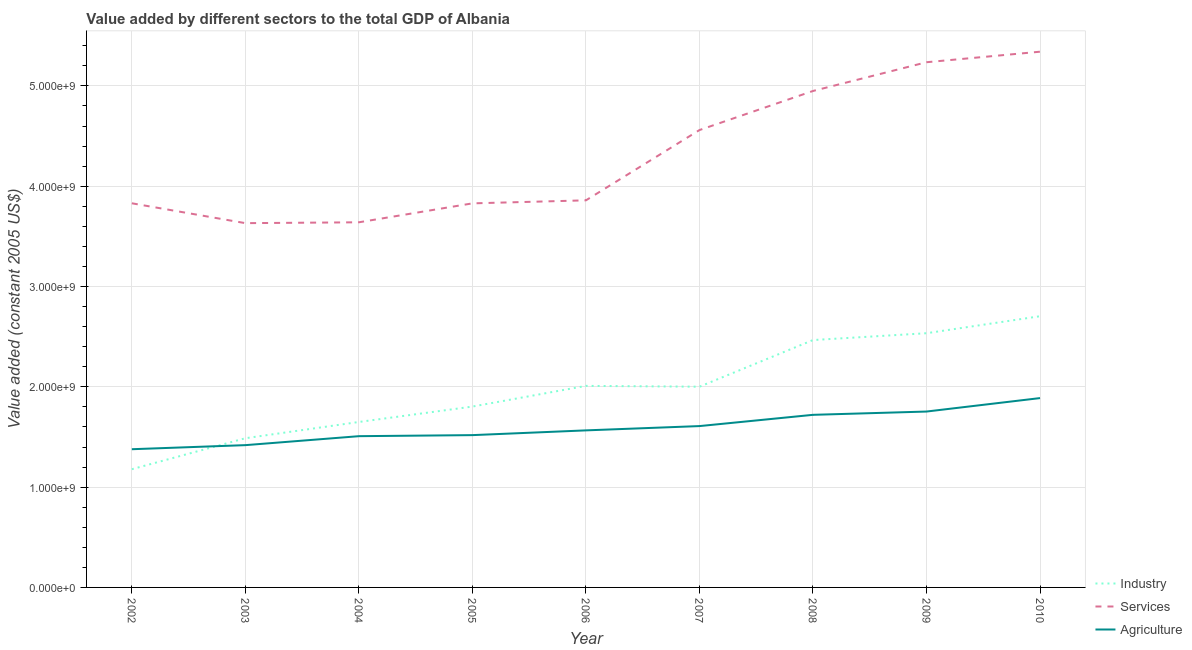Does the line corresponding to value added by services intersect with the line corresponding to value added by agricultural sector?
Your answer should be very brief. No. Is the number of lines equal to the number of legend labels?
Make the answer very short. Yes. What is the value added by industrial sector in 2009?
Provide a succinct answer. 2.53e+09. Across all years, what is the maximum value added by industrial sector?
Provide a short and direct response. 2.70e+09. Across all years, what is the minimum value added by industrial sector?
Offer a terse response. 1.18e+09. In which year was the value added by agricultural sector maximum?
Offer a terse response. 2010. What is the total value added by services in the graph?
Provide a short and direct response. 3.89e+1. What is the difference between the value added by industrial sector in 2008 and that in 2009?
Your answer should be very brief. -6.81e+07. What is the difference between the value added by industrial sector in 2008 and the value added by agricultural sector in 2005?
Your answer should be very brief. 9.48e+08. What is the average value added by agricultural sector per year?
Offer a terse response. 1.60e+09. In the year 2002, what is the difference between the value added by industrial sector and value added by services?
Give a very brief answer. -2.65e+09. What is the ratio of the value added by industrial sector in 2007 to that in 2010?
Ensure brevity in your answer.  0.74. What is the difference between the highest and the second highest value added by services?
Provide a succinct answer. 1.05e+08. What is the difference between the highest and the lowest value added by industrial sector?
Give a very brief answer. 1.53e+09. Is it the case that in every year, the sum of the value added by industrial sector and value added by services is greater than the value added by agricultural sector?
Your answer should be compact. Yes. Is the value added by services strictly greater than the value added by industrial sector over the years?
Your response must be concise. Yes. Is the value added by services strictly less than the value added by industrial sector over the years?
Keep it short and to the point. No. How many lines are there?
Your response must be concise. 3. What is the difference between two consecutive major ticks on the Y-axis?
Give a very brief answer. 1.00e+09. Are the values on the major ticks of Y-axis written in scientific E-notation?
Ensure brevity in your answer.  Yes. Does the graph contain grids?
Offer a very short reply. Yes. How are the legend labels stacked?
Offer a terse response. Vertical. What is the title of the graph?
Provide a short and direct response. Value added by different sectors to the total GDP of Albania. Does "Tertiary education" appear as one of the legend labels in the graph?
Provide a short and direct response. No. What is the label or title of the Y-axis?
Give a very brief answer. Value added (constant 2005 US$). What is the Value added (constant 2005 US$) in Industry in 2002?
Give a very brief answer. 1.18e+09. What is the Value added (constant 2005 US$) of Services in 2002?
Your answer should be very brief. 3.83e+09. What is the Value added (constant 2005 US$) in Agriculture in 2002?
Offer a very short reply. 1.38e+09. What is the Value added (constant 2005 US$) in Industry in 2003?
Your answer should be compact. 1.49e+09. What is the Value added (constant 2005 US$) of Services in 2003?
Your answer should be very brief. 3.63e+09. What is the Value added (constant 2005 US$) of Agriculture in 2003?
Ensure brevity in your answer.  1.42e+09. What is the Value added (constant 2005 US$) in Industry in 2004?
Offer a terse response. 1.65e+09. What is the Value added (constant 2005 US$) in Services in 2004?
Offer a terse response. 3.64e+09. What is the Value added (constant 2005 US$) in Agriculture in 2004?
Provide a succinct answer. 1.51e+09. What is the Value added (constant 2005 US$) in Industry in 2005?
Your answer should be very brief. 1.80e+09. What is the Value added (constant 2005 US$) of Services in 2005?
Make the answer very short. 3.83e+09. What is the Value added (constant 2005 US$) in Agriculture in 2005?
Your answer should be compact. 1.52e+09. What is the Value added (constant 2005 US$) of Industry in 2006?
Offer a terse response. 2.01e+09. What is the Value added (constant 2005 US$) in Services in 2006?
Keep it short and to the point. 3.86e+09. What is the Value added (constant 2005 US$) of Agriculture in 2006?
Provide a succinct answer. 1.57e+09. What is the Value added (constant 2005 US$) in Industry in 2007?
Give a very brief answer. 2.00e+09. What is the Value added (constant 2005 US$) in Services in 2007?
Provide a short and direct response. 4.56e+09. What is the Value added (constant 2005 US$) in Agriculture in 2007?
Your answer should be very brief. 1.61e+09. What is the Value added (constant 2005 US$) in Industry in 2008?
Give a very brief answer. 2.47e+09. What is the Value added (constant 2005 US$) of Services in 2008?
Your response must be concise. 4.95e+09. What is the Value added (constant 2005 US$) in Agriculture in 2008?
Offer a very short reply. 1.72e+09. What is the Value added (constant 2005 US$) of Industry in 2009?
Keep it short and to the point. 2.53e+09. What is the Value added (constant 2005 US$) of Services in 2009?
Your answer should be very brief. 5.24e+09. What is the Value added (constant 2005 US$) of Agriculture in 2009?
Your answer should be compact. 1.75e+09. What is the Value added (constant 2005 US$) of Industry in 2010?
Keep it short and to the point. 2.70e+09. What is the Value added (constant 2005 US$) of Services in 2010?
Provide a short and direct response. 5.34e+09. What is the Value added (constant 2005 US$) in Agriculture in 2010?
Your answer should be compact. 1.89e+09. Across all years, what is the maximum Value added (constant 2005 US$) in Industry?
Your answer should be very brief. 2.70e+09. Across all years, what is the maximum Value added (constant 2005 US$) in Services?
Make the answer very short. 5.34e+09. Across all years, what is the maximum Value added (constant 2005 US$) in Agriculture?
Offer a terse response. 1.89e+09. Across all years, what is the minimum Value added (constant 2005 US$) in Industry?
Ensure brevity in your answer.  1.18e+09. Across all years, what is the minimum Value added (constant 2005 US$) of Services?
Offer a very short reply. 3.63e+09. Across all years, what is the minimum Value added (constant 2005 US$) of Agriculture?
Keep it short and to the point. 1.38e+09. What is the total Value added (constant 2005 US$) in Industry in the graph?
Keep it short and to the point. 1.78e+1. What is the total Value added (constant 2005 US$) in Services in the graph?
Your answer should be very brief. 3.89e+1. What is the total Value added (constant 2005 US$) in Agriculture in the graph?
Your answer should be very brief. 1.44e+1. What is the difference between the Value added (constant 2005 US$) in Industry in 2002 and that in 2003?
Provide a short and direct response. -3.09e+08. What is the difference between the Value added (constant 2005 US$) in Services in 2002 and that in 2003?
Offer a terse response. 1.98e+08. What is the difference between the Value added (constant 2005 US$) of Agriculture in 2002 and that in 2003?
Your answer should be compact. -4.06e+07. What is the difference between the Value added (constant 2005 US$) in Industry in 2002 and that in 2004?
Ensure brevity in your answer.  -4.71e+08. What is the difference between the Value added (constant 2005 US$) of Services in 2002 and that in 2004?
Ensure brevity in your answer.  1.90e+08. What is the difference between the Value added (constant 2005 US$) in Agriculture in 2002 and that in 2004?
Your response must be concise. -1.30e+08. What is the difference between the Value added (constant 2005 US$) of Industry in 2002 and that in 2005?
Make the answer very short. -6.24e+08. What is the difference between the Value added (constant 2005 US$) of Services in 2002 and that in 2005?
Make the answer very short. 7.24e+05. What is the difference between the Value added (constant 2005 US$) of Agriculture in 2002 and that in 2005?
Your response must be concise. -1.40e+08. What is the difference between the Value added (constant 2005 US$) in Industry in 2002 and that in 2006?
Your answer should be compact. -8.31e+08. What is the difference between the Value added (constant 2005 US$) of Services in 2002 and that in 2006?
Ensure brevity in your answer.  -2.94e+07. What is the difference between the Value added (constant 2005 US$) in Agriculture in 2002 and that in 2006?
Provide a succinct answer. -1.88e+08. What is the difference between the Value added (constant 2005 US$) in Industry in 2002 and that in 2007?
Give a very brief answer. -8.23e+08. What is the difference between the Value added (constant 2005 US$) of Services in 2002 and that in 2007?
Your response must be concise. -7.30e+08. What is the difference between the Value added (constant 2005 US$) in Agriculture in 2002 and that in 2007?
Give a very brief answer. -2.31e+08. What is the difference between the Value added (constant 2005 US$) in Industry in 2002 and that in 2008?
Ensure brevity in your answer.  -1.29e+09. What is the difference between the Value added (constant 2005 US$) of Services in 2002 and that in 2008?
Provide a succinct answer. -1.12e+09. What is the difference between the Value added (constant 2005 US$) in Agriculture in 2002 and that in 2008?
Your answer should be compact. -3.43e+08. What is the difference between the Value added (constant 2005 US$) of Industry in 2002 and that in 2009?
Ensure brevity in your answer.  -1.36e+09. What is the difference between the Value added (constant 2005 US$) of Services in 2002 and that in 2009?
Your response must be concise. -1.41e+09. What is the difference between the Value added (constant 2005 US$) in Agriculture in 2002 and that in 2009?
Give a very brief answer. -3.76e+08. What is the difference between the Value added (constant 2005 US$) in Industry in 2002 and that in 2010?
Provide a succinct answer. -1.53e+09. What is the difference between the Value added (constant 2005 US$) in Services in 2002 and that in 2010?
Provide a succinct answer. -1.51e+09. What is the difference between the Value added (constant 2005 US$) in Agriculture in 2002 and that in 2010?
Offer a terse response. -5.10e+08. What is the difference between the Value added (constant 2005 US$) in Industry in 2003 and that in 2004?
Ensure brevity in your answer.  -1.62e+08. What is the difference between the Value added (constant 2005 US$) of Services in 2003 and that in 2004?
Give a very brief answer. -8.49e+06. What is the difference between the Value added (constant 2005 US$) in Agriculture in 2003 and that in 2004?
Ensure brevity in your answer.  -8.94e+07. What is the difference between the Value added (constant 2005 US$) of Industry in 2003 and that in 2005?
Provide a succinct answer. -3.16e+08. What is the difference between the Value added (constant 2005 US$) in Services in 2003 and that in 2005?
Make the answer very short. -1.97e+08. What is the difference between the Value added (constant 2005 US$) in Agriculture in 2003 and that in 2005?
Provide a succinct answer. -9.99e+07. What is the difference between the Value added (constant 2005 US$) in Industry in 2003 and that in 2006?
Keep it short and to the point. -5.22e+08. What is the difference between the Value added (constant 2005 US$) in Services in 2003 and that in 2006?
Your response must be concise. -2.27e+08. What is the difference between the Value added (constant 2005 US$) of Agriculture in 2003 and that in 2006?
Provide a short and direct response. -1.47e+08. What is the difference between the Value added (constant 2005 US$) in Industry in 2003 and that in 2007?
Offer a very short reply. -5.14e+08. What is the difference between the Value added (constant 2005 US$) in Services in 2003 and that in 2007?
Offer a very short reply. -9.28e+08. What is the difference between the Value added (constant 2005 US$) of Agriculture in 2003 and that in 2007?
Your answer should be compact. -1.90e+08. What is the difference between the Value added (constant 2005 US$) of Industry in 2003 and that in 2008?
Your answer should be compact. -9.79e+08. What is the difference between the Value added (constant 2005 US$) of Services in 2003 and that in 2008?
Your response must be concise. -1.32e+09. What is the difference between the Value added (constant 2005 US$) of Agriculture in 2003 and that in 2008?
Make the answer very short. -3.02e+08. What is the difference between the Value added (constant 2005 US$) in Industry in 2003 and that in 2009?
Keep it short and to the point. -1.05e+09. What is the difference between the Value added (constant 2005 US$) in Services in 2003 and that in 2009?
Keep it short and to the point. -1.60e+09. What is the difference between the Value added (constant 2005 US$) in Agriculture in 2003 and that in 2009?
Your response must be concise. -3.35e+08. What is the difference between the Value added (constant 2005 US$) in Industry in 2003 and that in 2010?
Offer a terse response. -1.22e+09. What is the difference between the Value added (constant 2005 US$) of Services in 2003 and that in 2010?
Ensure brevity in your answer.  -1.71e+09. What is the difference between the Value added (constant 2005 US$) of Agriculture in 2003 and that in 2010?
Make the answer very short. -4.69e+08. What is the difference between the Value added (constant 2005 US$) of Industry in 2004 and that in 2005?
Make the answer very short. -1.54e+08. What is the difference between the Value added (constant 2005 US$) of Services in 2004 and that in 2005?
Make the answer very short. -1.89e+08. What is the difference between the Value added (constant 2005 US$) in Agriculture in 2004 and that in 2005?
Provide a succinct answer. -1.05e+07. What is the difference between the Value added (constant 2005 US$) in Industry in 2004 and that in 2006?
Your answer should be very brief. -3.60e+08. What is the difference between the Value added (constant 2005 US$) in Services in 2004 and that in 2006?
Your answer should be compact. -2.19e+08. What is the difference between the Value added (constant 2005 US$) of Agriculture in 2004 and that in 2006?
Offer a terse response. -5.79e+07. What is the difference between the Value added (constant 2005 US$) of Industry in 2004 and that in 2007?
Provide a succinct answer. -3.52e+08. What is the difference between the Value added (constant 2005 US$) in Services in 2004 and that in 2007?
Give a very brief answer. -9.20e+08. What is the difference between the Value added (constant 2005 US$) of Agriculture in 2004 and that in 2007?
Make the answer very short. -1.01e+08. What is the difference between the Value added (constant 2005 US$) in Industry in 2004 and that in 2008?
Your response must be concise. -8.17e+08. What is the difference between the Value added (constant 2005 US$) of Services in 2004 and that in 2008?
Your response must be concise. -1.31e+09. What is the difference between the Value added (constant 2005 US$) of Agriculture in 2004 and that in 2008?
Provide a succinct answer. -2.13e+08. What is the difference between the Value added (constant 2005 US$) in Industry in 2004 and that in 2009?
Provide a short and direct response. -8.85e+08. What is the difference between the Value added (constant 2005 US$) in Services in 2004 and that in 2009?
Offer a terse response. -1.60e+09. What is the difference between the Value added (constant 2005 US$) in Agriculture in 2004 and that in 2009?
Give a very brief answer. -2.46e+08. What is the difference between the Value added (constant 2005 US$) of Industry in 2004 and that in 2010?
Provide a short and direct response. -1.05e+09. What is the difference between the Value added (constant 2005 US$) of Services in 2004 and that in 2010?
Ensure brevity in your answer.  -1.70e+09. What is the difference between the Value added (constant 2005 US$) of Agriculture in 2004 and that in 2010?
Give a very brief answer. -3.80e+08. What is the difference between the Value added (constant 2005 US$) of Industry in 2005 and that in 2006?
Provide a succinct answer. -2.06e+08. What is the difference between the Value added (constant 2005 US$) of Services in 2005 and that in 2006?
Offer a terse response. -3.01e+07. What is the difference between the Value added (constant 2005 US$) in Agriculture in 2005 and that in 2006?
Provide a short and direct response. -4.75e+07. What is the difference between the Value added (constant 2005 US$) in Industry in 2005 and that in 2007?
Ensure brevity in your answer.  -1.98e+08. What is the difference between the Value added (constant 2005 US$) of Services in 2005 and that in 2007?
Offer a terse response. -7.31e+08. What is the difference between the Value added (constant 2005 US$) of Agriculture in 2005 and that in 2007?
Provide a succinct answer. -9.02e+07. What is the difference between the Value added (constant 2005 US$) of Industry in 2005 and that in 2008?
Provide a succinct answer. -6.63e+08. What is the difference between the Value added (constant 2005 US$) in Services in 2005 and that in 2008?
Your answer should be very brief. -1.12e+09. What is the difference between the Value added (constant 2005 US$) of Agriculture in 2005 and that in 2008?
Offer a terse response. -2.02e+08. What is the difference between the Value added (constant 2005 US$) in Industry in 2005 and that in 2009?
Your response must be concise. -7.31e+08. What is the difference between the Value added (constant 2005 US$) in Services in 2005 and that in 2009?
Make the answer very short. -1.41e+09. What is the difference between the Value added (constant 2005 US$) in Agriculture in 2005 and that in 2009?
Offer a very short reply. -2.35e+08. What is the difference between the Value added (constant 2005 US$) in Industry in 2005 and that in 2010?
Provide a succinct answer. -9.01e+08. What is the difference between the Value added (constant 2005 US$) of Services in 2005 and that in 2010?
Provide a succinct answer. -1.51e+09. What is the difference between the Value added (constant 2005 US$) of Agriculture in 2005 and that in 2010?
Give a very brief answer. -3.69e+08. What is the difference between the Value added (constant 2005 US$) of Industry in 2006 and that in 2007?
Give a very brief answer. 8.20e+06. What is the difference between the Value added (constant 2005 US$) in Services in 2006 and that in 2007?
Keep it short and to the point. -7.01e+08. What is the difference between the Value added (constant 2005 US$) in Agriculture in 2006 and that in 2007?
Your response must be concise. -4.27e+07. What is the difference between the Value added (constant 2005 US$) in Industry in 2006 and that in 2008?
Your answer should be very brief. -4.57e+08. What is the difference between the Value added (constant 2005 US$) in Services in 2006 and that in 2008?
Provide a short and direct response. -1.09e+09. What is the difference between the Value added (constant 2005 US$) in Agriculture in 2006 and that in 2008?
Your answer should be very brief. -1.55e+08. What is the difference between the Value added (constant 2005 US$) in Industry in 2006 and that in 2009?
Provide a succinct answer. -5.25e+08. What is the difference between the Value added (constant 2005 US$) of Services in 2006 and that in 2009?
Keep it short and to the point. -1.38e+09. What is the difference between the Value added (constant 2005 US$) in Agriculture in 2006 and that in 2009?
Give a very brief answer. -1.88e+08. What is the difference between the Value added (constant 2005 US$) in Industry in 2006 and that in 2010?
Make the answer very short. -6.94e+08. What is the difference between the Value added (constant 2005 US$) in Services in 2006 and that in 2010?
Your answer should be very brief. -1.48e+09. What is the difference between the Value added (constant 2005 US$) of Agriculture in 2006 and that in 2010?
Your answer should be compact. -3.22e+08. What is the difference between the Value added (constant 2005 US$) of Industry in 2007 and that in 2008?
Offer a very short reply. -4.65e+08. What is the difference between the Value added (constant 2005 US$) in Services in 2007 and that in 2008?
Offer a very short reply. -3.90e+08. What is the difference between the Value added (constant 2005 US$) of Agriculture in 2007 and that in 2008?
Offer a very short reply. -1.12e+08. What is the difference between the Value added (constant 2005 US$) of Industry in 2007 and that in 2009?
Make the answer very short. -5.33e+08. What is the difference between the Value added (constant 2005 US$) in Services in 2007 and that in 2009?
Provide a succinct answer. -6.76e+08. What is the difference between the Value added (constant 2005 US$) in Agriculture in 2007 and that in 2009?
Make the answer very short. -1.45e+08. What is the difference between the Value added (constant 2005 US$) of Industry in 2007 and that in 2010?
Provide a short and direct response. -7.03e+08. What is the difference between the Value added (constant 2005 US$) in Services in 2007 and that in 2010?
Your answer should be very brief. -7.81e+08. What is the difference between the Value added (constant 2005 US$) in Agriculture in 2007 and that in 2010?
Provide a short and direct response. -2.79e+08. What is the difference between the Value added (constant 2005 US$) in Industry in 2008 and that in 2009?
Offer a terse response. -6.81e+07. What is the difference between the Value added (constant 2005 US$) in Services in 2008 and that in 2009?
Ensure brevity in your answer.  -2.87e+08. What is the difference between the Value added (constant 2005 US$) of Agriculture in 2008 and that in 2009?
Keep it short and to the point. -3.28e+07. What is the difference between the Value added (constant 2005 US$) of Industry in 2008 and that in 2010?
Give a very brief answer. -2.38e+08. What is the difference between the Value added (constant 2005 US$) in Services in 2008 and that in 2010?
Your answer should be compact. -3.92e+08. What is the difference between the Value added (constant 2005 US$) of Agriculture in 2008 and that in 2010?
Give a very brief answer. -1.67e+08. What is the difference between the Value added (constant 2005 US$) of Industry in 2009 and that in 2010?
Your response must be concise. -1.69e+08. What is the difference between the Value added (constant 2005 US$) of Services in 2009 and that in 2010?
Your answer should be compact. -1.05e+08. What is the difference between the Value added (constant 2005 US$) in Agriculture in 2009 and that in 2010?
Provide a short and direct response. -1.34e+08. What is the difference between the Value added (constant 2005 US$) in Industry in 2002 and the Value added (constant 2005 US$) in Services in 2003?
Provide a short and direct response. -2.45e+09. What is the difference between the Value added (constant 2005 US$) in Industry in 2002 and the Value added (constant 2005 US$) in Agriculture in 2003?
Make the answer very short. -2.40e+08. What is the difference between the Value added (constant 2005 US$) of Services in 2002 and the Value added (constant 2005 US$) of Agriculture in 2003?
Give a very brief answer. 2.41e+09. What is the difference between the Value added (constant 2005 US$) of Industry in 2002 and the Value added (constant 2005 US$) of Services in 2004?
Your response must be concise. -2.46e+09. What is the difference between the Value added (constant 2005 US$) of Industry in 2002 and the Value added (constant 2005 US$) of Agriculture in 2004?
Your answer should be compact. -3.29e+08. What is the difference between the Value added (constant 2005 US$) in Services in 2002 and the Value added (constant 2005 US$) in Agriculture in 2004?
Give a very brief answer. 2.32e+09. What is the difference between the Value added (constant 2005 US$) in Industry in 2002 and the Value added (constant 2005 US$) in Services in 2005?
Your response must be concise. -2.65e+09. What is the difference between the Value added (constant 2005 US$) in Industry in 2002 and the Value added (constant 2005 US$) in Agriculture in 2005?
Make the answer very short. -3.40e+08. What is the difference between the Value added (constant 2005 US$) in Services in 2002 and the Value added (constant 2005 US$) in Agriculture in 2005?
Ensure brevity in your answer.  2.31e+09. What is the difference between the Value added (constant 2005 US$) of Industry in 2002 and the Value added (constant 2005 US$) of Services in 2006?
Offer a terse response. -2.68e+09. What is the difference between the Value added (constant 2005 US$) of Industry in 2002 and the Value added (constant 2005 US$) of Agriculture in 2006?
Your response must be concise. -3.87e+08. What is the difference between the Value added (constant 2005 US$) of Services in 2002 and the Value added (constant 2005 US$) of Agriculture in 2006?
Provide a short and direct response. 2.26e+09. What is the difference between the Value added (constant 2005 US$) of Industry in 2002 and the Value added (constant 2005 US$) of Services in 2007?
Your response must be concise. -3.38e+09. What is the difference between the Value added (constant 2005 US$) in Industry in 2002 and the Value added (constant 2005 US$) in Agriculture in 2007?
Your answer should be very brief. -4.30e+08. What is the difference between the Value added (constant 2005 US$) of Services in 2002 and the Value added (constant 2005 US$) of Agriculture in 2007?
Make the answer very short. 2.22e+09. What is the difference between the Value added (constant 2005 US$) in Industry in 2002 and the Value added (constant 2005 US$) in Services in 2008?
Offer a terse response. -3.77e+09. What is the difference between the Value added (constant 2005 US$) in Industry in 2002 and the Value added (constant 2005 US$) in Agriculture in 2008?
Make the answer very short. -5.42e+08. What is the difference between the Value added (constant 2005 US$) of Services in 2002 and the Value added (constant 2005 US$) of Agriculture in 2008?
Make the answer very short. 2.11e+09. What is the difference between the Value added (constant 2005 US$) of Industry in 2002 and the Value added (constant 2005 US$) of Services in 2009?
Provide a short and direct response. -4.06e+09. What is the difference between the Value added (constant 2005 US$) in Industry in 2002 and the Value added (constant 2005 US$) in Agriculture in 2009?
Give a very brief answer. -5.75e+08. What is the difference between the Value added (constant 2005 US$) in Services in 2002 and the Value added (constant 2005 US$) in Agriculture in 2009?
Make the answer very short. 2.08e+09. What is the difference between the Value added (constant 2005 US$) of Industry in 2002 and the Value added (constant 2005 US$) of Services in 2010?
Keep it short and to the point. -4.16e+09. What is the difference between the Value added (constant 2005 US$) of Industry in 2002 and the Value added (constant 2005 US$) of Agriculture in 2010?
Make the answer very short. -7.09e+08. What is the difference between the Value added (constant 2005 US$) in Services in 2002 and the Value added (constant 2005 US$) in Agriculture in 2010?
Offer a very short reply. 1.94e+09. What is the difference between the Value added (constant 2005 US$) of Industry in 2003 and the Value added (constant 2005 US$) of Services in 2004?
Your answer should be compact. -2.15e+09. What is the difference between the Value added (constant 2005 US$) of Industry in 2003 and the Value added (constant 2005 US$) of Agriculture in 2004?
Ensure brevity in your answer.  -2.04e+07. What is the difference between the Value added (constant 2005 US$) of Services in 2003 and the Value added (constant 2005 US$) of Agriculture in 2004?
Ensure brevity in your answer.  2.12e+09. What is the difference between the Value added (constant 2005 US$) of Industry in 2003 and the Value added (constant 2005 US$) of Services in 2005?
Provide a succinct answer. -2.34e+09. What is the difference between the Value added (constant 2005 US$) in Industry in 2003 and the Value added (constant 2005 US$) in Agriculture in 2005?
Your answer should be compact. -3.09e+07. What is the difference between the Value added (constant 2005 US$) in Services in 2003 and the Value added (constant 2005 US$) in Agriculture in 2005?
Ensure brevity in your answer.  2.11e+09. What is the difference between the Value added (constant 2005 US$) of Industry in 2003 and the Value added (constant 2005 US$) of Services in 2006?
Your answer should be very brief. -2.37e+09. What is the difference between the Value added (constant 2005 US$) in Industry in 2003 and the Value added (constant 2005 US$) in Agriculture in 2006?
Provide a short and direct response. -7.83e+07. What is the difference between the Value added (constant 2005 US$) in Services in 2003 and the Value added (constant 2005 US$) in Agriculture in 2006?
Keep it short and to the point. 2.07e+09. What is the difference between the Value added (constant 2005 US$) of Industry in 2003 and the Value added (constant 2005 US$) of Services in 2007?
Provide a succinct answer. -3.07e+09. What is the difference between the Value added (constant 2005 US$) of Industry in 2003 and the Value added (constant 2005 US$) of Agriculture in 2007?
Make the answer very short. -1.21e+08. What is the difference between the Value added (constant 2005 US$) of Services in 2003 and the Value added (constant 2005 US$) of Agriculture in 2007?
Your response must be concise. 2.02e+09. What is the difference between the Value added (constant 2005 US$) of Industry in 2003 and the Value added (constant 2005 US$) of Services in 2008?
Provide a succinct answer. -3.46e+09. What is the difference between the Value added (constant 2005 US$) in Industry in 2003 and the Value added (constant 2005 US$) in Agriculture in 2008?
Keep it short and to the point. -2.33e+08. What is the difference between the Value added (constant 2005 US$) of Services in 2003 and the Value added (constant 2005 US$) of Agriculture in 2008?
Ensure brevity in your answer.  1.91e+09. What is the difference between the Value added (constant 2005 US$) of Industry in 2003 and the Value added (constant 2005 US$) of Services in 2009?
Offer a very short reply. -3.75e+09. What is the difference between the Value added (constant 2005 US$) in Industry in 2003 and the Value added (constant 2005 US$) in Agriculture in 2009?
Ensure brevity in your answer.  -2.66e+08. What is the difference between the Value added (constant 2005 US$) of Services in 2003 and the Value added (constant 2005 US$) of Agriculture in 2009?
Give a very brief answer. 1.88e+09. What is the difference between the Value added (constant 2005 US$) in Industry in 2003 and the Value added (constant 2005 US$) in Services in 2010?
Ensure brevity in your answer.  -3.85e+09. What is the difference between the Value added (constant 2005 US$) of Industry in 2003 and the Value added (constant 2005 US$) of Agriculture in 2010?
Ensure brevity in your answer.  -4.00e+08. What is the difference between the Value added (constant 2005 US$) of Services in 2003 and the Value added (constant 2005 US$) of Agriculture in 2010?
Offer a very short reply. 1.74e+09. What is the difference between the Value added (constant 2005 US$) of Industry in 2004 and the Value added (constant 2005 US$) of Services in 2005?
Your response must be concise. -2.18e+09. What is the difference between the Value added (constant 2005 US$) of Industry in 2004 and the Value added (constant 2005 US$) of Agriculture in 2005?
Give a very brief answer. 1.31e+08. What is the difference between the Value added (constant 2005 US$) in Services in 2004 and the Value added (constant 2005 US$) in Agriculture in 2005?
Ensure brevity in your answer.  2.12e+09. What is the difference between the Value added (constant 2005 US$) in Industry in 2004 and the Value added (constant 2005 US$) in Services in 2006?
Keep it short and to the point. -2.21e+09. What is the difference between the Value added (constant 2005 US$) of Industry in 2004 and the Value added (constant 2005 US$) of Agriculture in 2006?
Ensure brevity in your answer.  8.37e+07. What is the difference between the Value added (constant 2005 US$) in Services in 2004 and the Value added (constant 2005 US$) in Agriculture in 2006?
Offer a very short reply. 2.07e+09. What is the difference between the Value added (constant 2005 US$) of Industry in 2004 and the Value added (constant 2005 US$) of Services in 2007?
Your answer should be very brief. -2.91e+09. What is the difference between the Value added (constant 2005 US$) of Industry in 2004 and the Value added (constant 2005 US$) of Agriculture in 2007?
Provide a short and direct response. 4.09e+07. What is the difference between the Value added (constant 2005 US$) of Services in 2004 and the Value added (constant 2005 US$) of Agriculture in 2007?
Provide a succinct answer. 2.03e+09. What is the difference between the Value added (constant 2005 US$) of Industry in 2004 and the Value added (constant 2005 US$) of Services in 2008?
Offer a terse response. -3.30e+09. What is the difference between the Value added (constant 2005 US$) of Industry in 2004 and the Value added (constant 2005 US$) of Agriculture in 2008?
Your answer should be compact. -7.13e+07. What is the difference between the Value added (constant 2005 US$) of Services in 2004 and the Value added (constant 2005 US$) of Agriculture in 2008?
Ensure brevity in your answer.  1.92e+09. What is the difference between the Value added (constant 2005 US$) of Industry in 2004 and the Value added (constant 2005 US$) of Services in 2009?
Your response must be concise. -3.59e+09. What is the difference between the Value added (constant 2005 US$) in Industry in 2004 and the Value added (constant 2005 US$) in Agriculture in 2009?
Keep it short and to the point. -1.04e+08. What is the difference between the Value added (constant 2005 US$) of Services in 2004 and the Value added (constant 2005 US$) of Agriculture in 2009?
Your response must be concise. 1.89e+09. What is the difference between the Value added (constant 2005 US$) of Industry in 2004 and the Value added (constant 2005 US$) of Services in 2010?
Ensure brevity in your answer.  -3.69e+09. What is the difference between the Value added (constant 2005 US$) in Industry in 2004 and the Value added (constant 2005 US$) in Agriculture in 2010?
Your answer should be very brief. -2.38e+08. What is the difference between the Value added (constant 2005 US$) in Services in 2004 and the Value added (constant 2005 US$) in Agriculture in 2010?
Your answer should be very brief. 1.75e+09. What is the difference between the Value added (constant 2005 US$) of Industry in 2005 and the Value added (constant 2005 US$) of Services in 2006?
Offer a very short reply. -2.06e+09. What is the difference between the Value added (constant 2005 US$) in Industry in 2005 and the Value added (constant 2005 US$) in Agriculture in 2006?
Your response must be concise. 2.37e+08. What is the difference between the Value added (constant 2005 US$) of Services in 2005 and the Value added (constant 2005 US$) of Agriculture in 2006?
Make the answer very short. 2.26e+09. What is the difference between the Value added (constant 2005 US$) of Industry in 2005 and the Value added (constant 2005 US$) of Services in 2007?
Provide a succinct answer. -2.76e+09. What is the difference between the Value added (constant 2005 US$) in Industry in 2005 and the Value added (constant 2005 US$) in Agriculture in 2007?
Offer a very short reply. 1.95e+08. What is the difference between the Value added (constant 2005 US$) in Services in 2005 and the Value added (constant 2005 US$) in Agriculture in 2007?
Give a very brief answer. 2.22e+09. What is the difference between the Value added (constant 2005 US$) of Industry in 2005 and the Value added (constant 2005 US$) of Services in 2008?
Make the answer very short. -3.15e+09. What is the difference between the Value added (constant 2005 US$) in Industry in 2005 and the Value added (constant 2005 US$) in Agriculture in 2008?
Ensure brevity in your answer.  8.24e+07. What is the difference between the Value added (constant 2005 US$) in Services in 2005 and the Value added (constant 2005 US$) in Agriculture in 2008?
Your response must be concise. 2.11e+09. What is the difference between the Value added (constant 2005 US$) of Industry in 2005 and the Value added (constant 2005 US$) of Services in 2009?
Offer a very short reply. -3.43e+09. What is the difference between the Value added (constant 2005 US$) in Industry in 2005 and the Value added (constant 2005 US$) in Agriculture in 2009?
Give a very brief answer. 4.96e+07. What is the difference between the Value added (constant 2005 US$) of Services in 2005 and the Value added (constant 2005 US$) of Agriculture in 2009?
Your answer should be compact. 2.08e+09. What is the difference between the Value added (constant 2005 US$) of Industry in 2005 and the Value added (constant 2005 US$) of Services in 2010?
Your answer should be compact. -3.54e+09. What is the difference between the Value added (constant 2005 US$) in Industry in 2005 and the Value added (constant 2005 US$) in Agriculture in 2010?
Give a very brief answer. -8.45e+07. What is the difference between the Value added (constant 2005 US$) of Services in 2005 and the Value added (constant 2005 US$) of Agriculture in 2010?
Provide a succinct answer. 1.94e+09. What is the difference between the Value added (constant 2005 US$) in Industry in 2006 and the Value added (constant 2005 US$) in Services in 2007?
Your response must be concise. -2.55e+09. What is the difference between the Value added (constant 2005 US$) of Industry in 2006 and the Value added (constant 2005 US$) of Agriculture in 2007?
Your response must be concise. 4.01e+08. What is the difference between the Value added (constant 2005 US$) in Services in 2006 and the Value added (constant 2005 US$) in Agriculture in 2007?
Your response must be concise. 2.25e+09. What is the difference between the Value added (constant 2005 US$) in Industry in 2006 and the Value added (constant 2005 US$) in Services in 2008?
Make the answer very short. -2.94e+09. What is the difference between the Value added (constant 2005 US$) of Industry in 2006 and the Value added (constant 2005 US$) of Agriculture in 2008?
Offer a very short reply. 2.89e+08. What is the difference between the Value added (constant 2005 US$) of Services in 2006 and the Value added (constant 2005 US$) of Agriculture in 2008?
Offer a terse response. 2.14e+09. What is the difference between the Value added (constant 2005 US$) of Industry in 2006 and the Value added (constant 2005 US$) of Services in 2009?
Make the answer very short. -3.23e+09. What is the difference between the Value added (constant 2005 US$) of Industry in 2006 and the Value added (constant 2005 US$) of Agriculture in 2009?
Keep it short and to the point. 2.56e+08. What is the difference between the Value added (constant 2005 US$) in Services in 2006 and the Value added (constant 2005 US$) in Agriculture in 2009?
Offer a very short reply. 2.11e+09. What is the difference between the Value added (constant 2005 US$) in Industry in 2006 and the Value added (constant 2005 US$) in Services in 2010?
Ensure brevity in your answer.  -3.33e+09. What is the difference between the Value added (constant 2005 US$) in Industry in 2006 and the Value added (constant 2005 US$) in Agriculture in 2010?
Offer a terse response. 1.22e+08. What is the difference between the Value added (constant 2005 US$) in Services in 2006 and the Value added (constant 2005 US$) in Agriculture in 2010?
Your response must be concise. 1.97e+09. What is the difference between the Value added (constant 2005 US$) in Industry in 2007 and the Value added (constant 2005 US$) in Services in 2008?
Your answer should be compact. -2.95e+09. What is the difference between the Value added (constant 2005 US$) in Industry in 2007 and the Value added (constant 2005 US$) in Agriculture in 2008?
Your response must be concise. 2.80e+08. What is the difference between the Value added (constant 2005 US$) in Services in 2007 and the Value added (constant 2005 US$) in Agriculture in 2008?
Your response must be concise. 2.84e+09. What is the difference between the Value added (constant 2005 US$) of Industry in 2007 and the Value added (constant 2005 US$) of Services in 2009?
Provide a succinct answer. -3.23e+09. What is the difference between the Value added (constant 2005 US$) of Industry in 2007 and the Value added (constant 2005 US$) of Agriculture in 2009?
Your response must be concise. 2.48e+08. What is the difference between the Value added (constant 2005 US$) of Services in 2007 and the Value added (constant 2005 US$) of Agriculture in 2009?
Provide a succinct answer. 2.81e+09. What is the difference between the Value added (constant 2005 US$) in Industry in 2007 and the Value added (constant 2005 US$) in Services in 2010?
Your answer should be compact. -3.34e+09. What is the difference between the Value added (constant 2005 US$) in Industry in 2007 and the Value added (constant 2005 US$) in Agriculture in 2010?
Ensure brevity in your answer.  1.14e+08. What is the difference between the Value added (constant 2005 US$) of Services in 2007 and the Value added (constant 2005 US$) of Agriculture in 2010?
Offer a very short reply. 2.67e+09. What is the difference between the Value added (constant 2005 US$) of Industry in 2008 and the Value added (constant 2005 US$) of Services in 2009?
Your answer should be very brief. -2.77e+09. What is the difference between the Value added (constant 2005 US$) in Industry in 2008 and the Value added (constant 2005 US$) in Agriculture in 2009?
Offer a terse response. 7.13e+08. What is the difference between the Value added (constant 2005 US$) of Services in 2008 and the Value added (constant 2005 US$) of Agriculture in 2009?
Ensure brevity in your answer.  3.20e+09. What is the difference between the Value added (constant 2005 US$) in Industry in 2008 and the Value added (constant 2005 US$) in Services in 2010?
Provide a succinct answer. -2.87e+09. What is the difference between the Value added (constant 2005 US$) of Industry in 2008 and the Value added (constant 2005 US$) of Agriculture in 2010?
Give a very brief answer. 5.79e+08. What is the difference between the Value added (constant 2005 US$) of Services in 2008 and the Value added (constant 2005 US$) of Agriculture in 2010?
Your answer should be compact. 3.06e+09. What is the difference between the Value added (constant 2005 US$) in Industry in 2009 and the Value added (constant 2005 US$) in Services in 2010?
Make the answer very short. -2.81e+09. What is the difference between the Value added (constant 2005 US$) in Industry in 2009 and the Value added (constant 2005 US$) in Agriculture in 2010?
Offer a very short reply. 6.47e+08. What is the difference between the Value added (constant 2005 US$) in Services in 2009 and the Value added (constant 2005 US$) in Agriculture in 2010?
Make the answer very short. 3.35e+09. What is the average Value added (constant 2005 US$) in Industry per year?
Offer a very short reply. 1.98e+09. What is the average Value added (constant 2005 US$) of Services per year?
Your response must be concise. 4.32e+09. What is the average Value added (constant 2005 US$) of Agriculture per year?
Keep it short and to the point. 1.60e+09. In the year 2002, what is the difference between the Value added (constant 2005 US$) in Industry and Value added (constant 2005 US$) in Services?
Your answer should be very brief. -2.65e+09. In the year 2002, what is the difference between the Value added (constant 2005 US$) in Industry and Value added (constant 2005 US$) in Agriculture?
Give a very brief answer. -1.99e+08. In the year 2002, what is the difference between the Value added (constant 2005 US$) in Services and Value added (constant 2005 US$) in Agriculture?
Your response must be concise. 2.45e+09. In the year 2003, what is the difference between the Value added (constant 2005 US$) of Industry and Value added (constant 2005 US$) of Services?
Your answer should be compact. -2.14e+09. In the year 2003, what is the difference between the Value added (constant 2005 US$) in Industry and Value added (constant 2005 US$) in Agriculture?
Provide a short and direct response. 6.90e+07. In the year 2003, what is the difference between the Value added (constant 2005 US$) of Services and Value added (constant 2005 US$) of Agriculture?
Provide a short and direct response. 2.21e+09. In the year 2004, what is the difference between the Value added (constant 2005 US$) of Industry and Value added (constant 2005 US$) of Services?
Provide a short and direct response. -1.99e+09. In the year 2004, what is the difference between the Value added (constant 2005 US$) of Industry and Value added (constant 2005 US$) of Agriculture?
Your answer should be very brief. 1.42e+08. In the year 2004, what is the difference between the Value added (constant 2005 US$) of Services and Value added (constant 2005 US$) of Agriculture?
Ensure brevity in your answer.  2.13e+09. In the year 2005, what is the difference between the Value added (constant 2005 US$) of Industry and Value added (constant 2005 US$) of Services?
Offer a very short reply. -2.03e+09. In the year 2005, what is the difference between the Value added (constant 2005 US$) of Industry and Value added (constant 2005 US$) of Agriculture?
Ensure brevity in your answer.  2.85e+08. In the year 2005, what is the difference between the Value added (constant 2005 US$) of Services and Value added (constant 2005 US$) of Agriculture?
Offer a terse response. 2.31e+09. In the year 2006, what is the difference between the Value added (constant 2005 US$) in Industry and Value added (constant 2005 US$) in Services?
Ensure brevity in your answer.  -1.85e+09. In the year 2006, what is the difference between the Value added (constant 2005 US$) of Industry and Value added (constant 2005 US$) of Agriculture?
Offer a very short reply. 4.44e+08. In the year 2006, what is the difference between the Value added (constant 2005 US$) of Services and Value added (constant 2005 US$) of Agriculture?
Make the answer very short. 2.29e+09. In the year 2007, what is the difference between the Value added (constant 2005 US$) in Industry and Value added (constant 2005 US$) in Services?
Your answer should be compact. -2.56e+09. In the year 2007, what is the difference between the Value added (constant 2005 US$) of Industry and Value added (constant 2005 US$) of Agriculture?
Your answer should be very brief. 3.93e+08. In the year 2007, what is the difference between the Value added (constant 2005 US$) of Services and Value added (constant 2005 US$) of Agriculture?
Keep it short and to the point. 2.95e+09. In the year 2008, what is the difference between the Value added (constant 2005 US$) of Industry and Value added (constant 2005 US$) of Services?
Ensure brevity in your answer.  -2.48e+09. In the year 2008, what is the difference between the Value added (constant 2005 US$) of Industry and Value added (constant 2005 US$) of Agriculture?
Your answer should be compact. 7.46e+08. In the year 2008, what is the difference between the Value added (constant 2005 US$) of Services and Value added (constant 2005 US$) of Agriculture?
Ensure brevity in your answer.  3.23e+09. In the year 2009, what is the difference between the Value added (constant 2005 US$) of Industry and Value added (constant 2005 US$) of Services?
Your answer should be very brief. -2.70e+09. In the year 2009, what is the difference between the Value added (constant 2005 US$) in Industry and Value added (constant 2005 US$) in Agriculture?
Your answer should be compact. 7.81e+08. In the year 2009, what is the difference between the Value added (constant 2005 US$) in Services and Value added (constant 2005 US$) in Agriculture?
Provide a succinct answer. 3.48e+09. In the year 2010, what is the difference between the Value added (constant 2005 US$) of Industry and Value added (constant 2005 US$) of Services?
Make the answer very short. -2.64e+09. In the year 2010, what is the difference between the Value added (constant 2005 US$) of Industry and Value added (constant 2005 US$) of Agriculture?
Offer a terse response. 8.16e+08. In the year 2010, what is the difference between the Value added (constant 2005 US$) of Services and Value added (constant 2005 US$) of Agriculture?
Make the answer very short. 3.45e+09. What is the ratio of the Value added (constant 2005 US$) of Industry in 2002 to that in 2003?
Your answer should be compact. 0.79. What is the ratio of the Value added (constant 2005 US$) in Services in 2002 to that in 2003?
Ensure brevity in your answer.  1.05. What is the ratio of the Value added (constant 2005 US$) of Agriculture in 2002 to that in 2003?
Make the answer very short. 0.97. What is the ratio of the Value added (constant 2005 US$) of Industry in 2002 to that in 2004?
Your answer should be compact. 0.71. What is the ratio of the Value added (constant 2005 US$) in Services in 2002 to that in 2004?
Provide a succinct answer. 1.05. What is the ratio of the Value added (constant 2005 US$) in Agriculture in 2002 to that in 2004?
Your response must be concise. 0.91. What is the ratio of the Value added (constant 2005 US$) in Industry in 2002 to that in 2005?
Ensure brevity in your answer.  0.65. What is the ratio of the Value added (constant 2005 US$) in Services in 2002 to that in 2005?
Make the answer very short. 1. What is the ratio of the Value added (constant 2005 US$) in Agriculture in 2002 to that in 2005?
Provide a succinct answer. 0.91. What is the ratio of the Value added (constant 2005 US$) in Industry in 2002 to that in 2006?
Keep it short and to the point. 0.59. What is the ratio of the Value added (constant 2005 US$) of Agriculture in 2002 to that in 2006?
Keep it short and to the point. 0.88. What is the ratio of the Value added (constant 2005 US$) of Industry in 2002 to that in 2007?
Ensure brevity in your answer.  0.59. What is the ratio of the Value added (constant 2005 US$) in Services in 2002 to that in 2007?
Offer a terse response. 0.84. What is the ratio of the Value added (constant 2005 US$) in Agriculture in 2002 to that in 2007?
Ensure brevity in your answer.  0.86. What is the ratio of the Value added (constant 2005 US$) in Industry in 2002 to that in 2008?
Your answer should be very brief. 0.48. What is the ratio of the Value added (constant 2005 US$) in Services in 2002 to that in 2008?
Ensure brevity in your answer.  0.77. What is the ratio of the Value added (constant 2005 US$) in Agriculture in 2002 to that in 2008?
Make the answer very short. 0.8. What is the ratio of the Value added (constant 2005 US$) of Industry in 2002 to that in 2009?
Offer a very short reply. 0.47. What is the ratio of the Value added (constant 2005 US$) of Services in 2002 to that in 2009?
Your answer should be very brief. 0.73. What is the ratio of the Value added (constant 2005 US$) in Agriculture in 2002 to that in 2009?
Provide a short and direct response. 0.79. What is the ratio of the Value added (constant 2005 US$) of Industry in 2002 to that in 2010?
Keep it short and to the point. 0.44. What is the ratio of the Value added (constant 2005 US$) in Services in 2002 to that in 2010?
Your answer should be compact. 0.72. What is the ratio of the Value added (constant 2005 US$) in Agriculture in 2002 to that in 2010?
Offer a very short reply. 0.73. What is the ratio of the Value added (constant 2005 US$) of Industry in 2003 to that in 2004?
Your response must be concise. 0.9. What is the ratio of the Value added (constant 2005 US$) of Agriculture in 2003 to that in 2004?
Offer a very short reply. 0.94. What is the ratio of the Value added (constant 2005 US$) of Industry in 2003 to that in 2005?
Your response must be concise. 0.82. What is the ratio of the Value added (constant 2005 US$) in Services in 2003 to that in 2005?
Make the answer very short. 0.95. What is the ratio of the Value added (constant 2005 US$) in Agriculture in 2003 to that in 2005?
Provide a succinct answer. 0.93. What is the ratio of the Value added (constant 2005 US$) in Industry in 2003 to that in 2006?
Offer a terse response. 0.74. What is the ratio of the Value added (constant 2005 US$) of Services in 2003 to that in 2006?
Provide a succinct answer. 0.94. What is the ratio of the Value added (constant 2005 US$) in Agriculture in 2003 to that in 2006?
Offer a terse response. 0.91. What is the ratio of the Value added (constant 2005 US$) of Industry in 2003 to that in 2007?
Give a very brief answer. 0.74. What is the ratio of the Value added (constant 2005 US$) of Services in 2003 to that in 2007?
Your response must be concise. 0.8. What is the ratio of the Value added (constant 2005 US$) of Agriculture in 2003 to that in 2007?
Your answer should be compact. 0.88. What is the ratio of the Value added (constant 2005 US$) in Industry in 2003 to that in 2008?
Offer a very short reply. 0.6. What is the ratio of the Value added (constant 2005 US$) of Services in 2003 to that in 2008?
Ensure brevity in your answer.  0.73. What is the ratio of the Value added (constant 2005 US$) in Agriculture in 2003 to that in 2008?
Your answer should be very brief. 0.82. What is the ratio of the Value added (constant 2005 US$) in Industry in 2003 to that in 2009?
Offer a very short reply. 0.59. What is the ratio of the Value added (constant 2005 US$) of Services in 2003 to that in 2009?
Offer a very short reply. 0.69. What is the ratio of the Value added (constant 2005 US$) in Agriculture in 2003 to that in 2009?
Provide a succinct answer. 0.81. What is the ratio of the Value added (constant 2005 US$) in Industry in 2003 to that in 2010?
Ensure brevity in your answer.  0.55. What is the ratio of the Value added (constant 2005 US$) of Services in 2003 to that in 2010?
Provide a short and direct response. 0.68. What is the ratio of the Value added (constant 2005 US$) of Agriculture in 2003 to that in 2010?
Offer a very short reply. 0.75. What is the ratio of the Value added (constant 2005 US$) of Industry in 2004 to that in 2005?
Ensure brevity in your answer.  0.91. What is the ratio of the Value added (constant 2005 US$) of Services in 2004 to that in 2005?
Your response must be concise. 0.95. What is the ratio of the Value added (constant 2005 US$) in Agriculture in 2004 to that in 2005?
Provide a short and direct response. 0.99. What is the ratio of the Value added (constant 2005 US$) in Industry in 2004 to that in 2006?
Offer a terse response. 0.82. What is the ratio of the Value added (constant 2005 US$) of Services in 2004 to that in 2006?
Ensure brevity in your answer.  0.94. What is the ratio of the Value added (constant 2005 US$) in Agriculture in 2004 to that in 2006?
Provide a short and direct response. 0.96. What is the ratio of the Value added (constant 2005 US$) in Industry in 2004 to that in 2007?
Provide a short and direct response. 0.82. What is the ratio of the Value added (constant 2005 US$) of Services in 2004 to that in 2007?
Ensure brevity in your answer.  0.8. What is the ratio of the Value added (constant 2005 US$) of Agriculture in 2004 to that in 2007?
Ensure brevity in your answer.  0.94. What is the ratio of the Value added (constant 2005 US$) of Industry in 2004 to that in 2008?
Your response must be concise. 0.67. What is the ratio of the Value added (constant 2005 US$) of Services in 2004 to that in 2008?
Your answer should be very brief. 0.74. What is the ratio of the Value added (constant 2005 US$) of Agriculture in 2004 to that in 2008?
Ensure brevity in your answer.  0.88. What is the ratio of the Value added (constant 2005 US$) in Industry in 2004 to that in 2009?
Provide a succinct answer. 0.65. What is the ratio of the Value added (constant 2005 US$) in Services in 2004 to that in 2009?
Your answer should be compact. 0.7. What is the ratio of the Value added (constant 2005 US$) of Agriculture in 2004 to that in 2009?
Keep it short and to the point. 0.86. What is the ratio of the Value added (constant 2005 US$) in Industry in 2004 to that in 2010?
Make the answer very short. 0.61. What is the ratio of the Value added (constant 2005 US$) in Services in 2004 to that in 2010?
Keep it short and to the point. 0.68. What is the ratio of the Value added (constant 2005 US$) in Agriculture in 2004 to that in 2010?
Your response must be concise. 0.8. What is the ratio of the Value added (constant 2005 US$) of Industry in 2005 to that in 2006?
Your response must be concise. 0.9. What is the ratio of the Value added (constant 2005 US$) in Agriculture in 2005 to that in 2006?
Make the answer very short. 0.97. What is the ratio of the Value added (constant 2005 US$) of Industry in 2005 to that in 2007?
Ensure brevity in your answer.  0.9. What is the ratio of the Value added (constant 2005 US$) of Services in 2005 to that in 2007?
Your response must be concise. 0.84. What is the ratio of the Value added (constant 2005 US$) in Agriculture in 2005 to that in 2007?
Provide a succinct answer. 0.94. What is the ratio of the Value added (constant 2005 US$) in Industry in 2005 to that in 2008?
Keep it short and to the point. 0.73. What is the ratio of the Value added (constant 2005 US$) in Services in 2005 to that in 2008?
Your response must be concise. 0.77. What is the ratio of the Value added (constant 2005 US$) of Agriculture in 2005 to that in 2008?
Your response must be concise. 0.88. What is the ratio of the Value added (constant 2005 US$) of Industry in 2005 to that in 2009?
Provide a succinct answer. 0.71. What is the ratio of the Value added (constant 2005 US$) in Services in 2005 to that in 2009?
Provide a short and direct response. 0.73. What is the ratio of the Value added (constant 2005 US$) of Agriculture in 2005 to that in 2009?
Your answer should be very brief. 0.87. What is the ratio of the Value added (constant 2005 US$) in Industry in 2005 to that in 2010?
Offer a terse response. 0.67. What is the ratio of the Value added (constant 2005 US$) of Services in 2005 to that in 2010?
Provide a short and direct response. 0.72. What is the ratio of the Value added (constant 2005 US$) of Agriculture in 2005 to that in 2010?
Provide a succinct answer. 0.8. What is the ratio of the Value added (constant 2005 US$) of Services in 2006 to that in 2007?
Provide a short and direct response. 0.85. What is the ratio of the Value added (constant 2005 US$) in Agriculture in 2006 to that in 2007?
Keep it short and to the point. 0.97. What is the ratio of the Value added (constant 2005 US$) of Industry in 2006 to that in 2008?
Give a very brief answer. 0.81. What is the ratio of the Value added (constant 2005 US$) in Services in 2006 to that in 2008?
Your answer should be compact. 0.78. What is the ratio of the Value added (constant 2005 US$) of Agriculture in 2006 to that in 2008?
Keep it short and to the point. 0.91. What is the ratio of the Value added (constant 2005 US$) of Industry in 2006 to that in 2009?
Keep it short and to the point. 0.79. What is the ratio of the Value added (constant 2005 US$) of Services in 2006 to that in 2009?
Give a very brief answer. 0.74. What is the ratio of the Value added (constant 2005 US$) in Agriculture in 2006 to that in 2009?
Your response must be concise. 0.89. What is the ratio of the Value added (constant 2005 US$) of Industry in 2006 to that in 2010?
Provide a short and direct response. 0.74. What is the ratio of the Value added (constant 2005 US$) in Services in 2006 to that in 2010?
Offer a terse response. 0.72. What is the ratio of the Value added (constant 2005 US$) in Agriculture in 2006 to that in 2010?
Make the answer very short. 0.83. What is the ratio of the Value added (constant 2005 US$) of Industry in 2007 to that in 2008?
Provide a succinct answer. 0.81. What is the ratio of the Value added (constant 2005 US$) in Services in 2007 to that in 2008?
Offer a very short reply. 0.92. What is the ratio of the Value added (constant 2005 US$) of Agriculture in 2007 to that in 2008?
Your answer should be very brief. 0.93. What is the ratio of the Value added (constant 2005 US$) of Industry in 2007 to that in 2009?
Provide a short and direct response. 0.79. What is the ratio of the Value added (constant 2005 US$) in Services in 2007 to that in 2009?
Offer a very short reply. 0.87. What is the ratio of the Value added (constant 2005 US$) in Agriculture in 2007 to that in 2009?
Make the answer very short. 0.92. What is the ratio of the Value added (constant 2005 US$) in Industry in 2007 to that in 2010?
Offer a very short reply. 0.74. What is the ratio of the Value added (constant 2005 US$) in Services in 2007 to that in 2010?
Ensure brevity in your answer.  0.85. What is the ratio of the Value added (constant 2005 US$) of Agriculture in 2007 to that in 2010?
Your answer should be very brief. 0.85. What is the ratio of the Value added (constant 2005 US$) in Industry in 2008 to that in 2009?
Offer a terse response. 0.97. What is the ratio of the Value added (constant 2005 US$) of Services in 2008 to that in 2009?
Your answer should be very brief. 0.95. What is the ratio of the Value added (constant 2005 US$) of Agriculture in 2008 to that in 2009?
Ensure brevity in your answer.  0.98. What is the ratio of the Value added (constant 2005 US$) in Industry in 2008 to that in 2010?
Offer a very short reply. 0.91. What is the ratio of the Value added (constant 2005 US$) in Services in 2008 to that in 2010?
Your answer should be very brief. 0.93. What is the ratio of the Value added (constant 2005 US$) of Agriculture in 2008 to that in 2010?
Make the answer very short. 0.91. What is the ratio of the Value added (constant 2005 US$) in Industry in 2009 to that in 2010?
Provide a short and direct response. 0.94. What is the ratio of the Value added (constant 2005 US$) in Services in 2009 to that in 2010?
Make the answer very short. 0.98. What is the ratio of the Value added (constant 2005 US$) in Agriculture in 2009 to that in 2010?
Provide a succinct answer. 0.93. What is the difference between the highest and the second highest Value added (constant 2005 US$) of Industry?
Offer a terse response. 1.69e+08. What is the difference between the highest and the second highest Value added (constant 2005 US$) in Services?
Keep it short and to the point. 1.05e+08. What is the difference between the highest and the second highest Value added (constant 2005 US$) of Agriculture?
Your answer should be compact. 1.34e+08. What is the difference between the highest and the lowest Value added (constant 2005 US$) in Industry?
Ensure brevity in your answer.  1.53e+09. What is the difference between the highest and the lowest Value added (constant 2005 US$) of Services?
Provide a succinct answer. 1.71e+09. What is the difference between the highest and the lowest Value added (constant 2005 US$) in Agriculture?
Provide a succinct answer. 5.10e+08. 